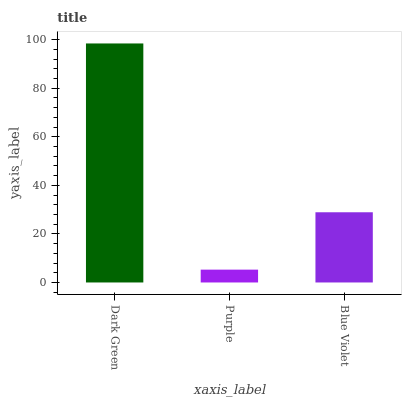Is Purple the minimum?
Answer yes or no. Yes. Is Dark Green the maximum?
Answer yes or no. Yes. Is Blue Violet the minimum?
Answer yes or no. No. Is Blue Violet the maximum?
Answer yes or no. No. Is Blue Violet greater than Purple?
Answer yes or no. Yes. Is Purple less than Blue Violet?
Answer yes or no. Yes. Is Purple greater than Blue Violet?
Answer yes or no. No. Is Blue Violet less than Purple?
Answer yes or no. No. Is Blue Violet the high median?
Answer yes or no. Yes. Is Blue Violet the low median?
Answer yes or no. Yes. Is Purple the high median?
Answer yes or no. No. Is Purple the low median?
Answer yes or no. No. 